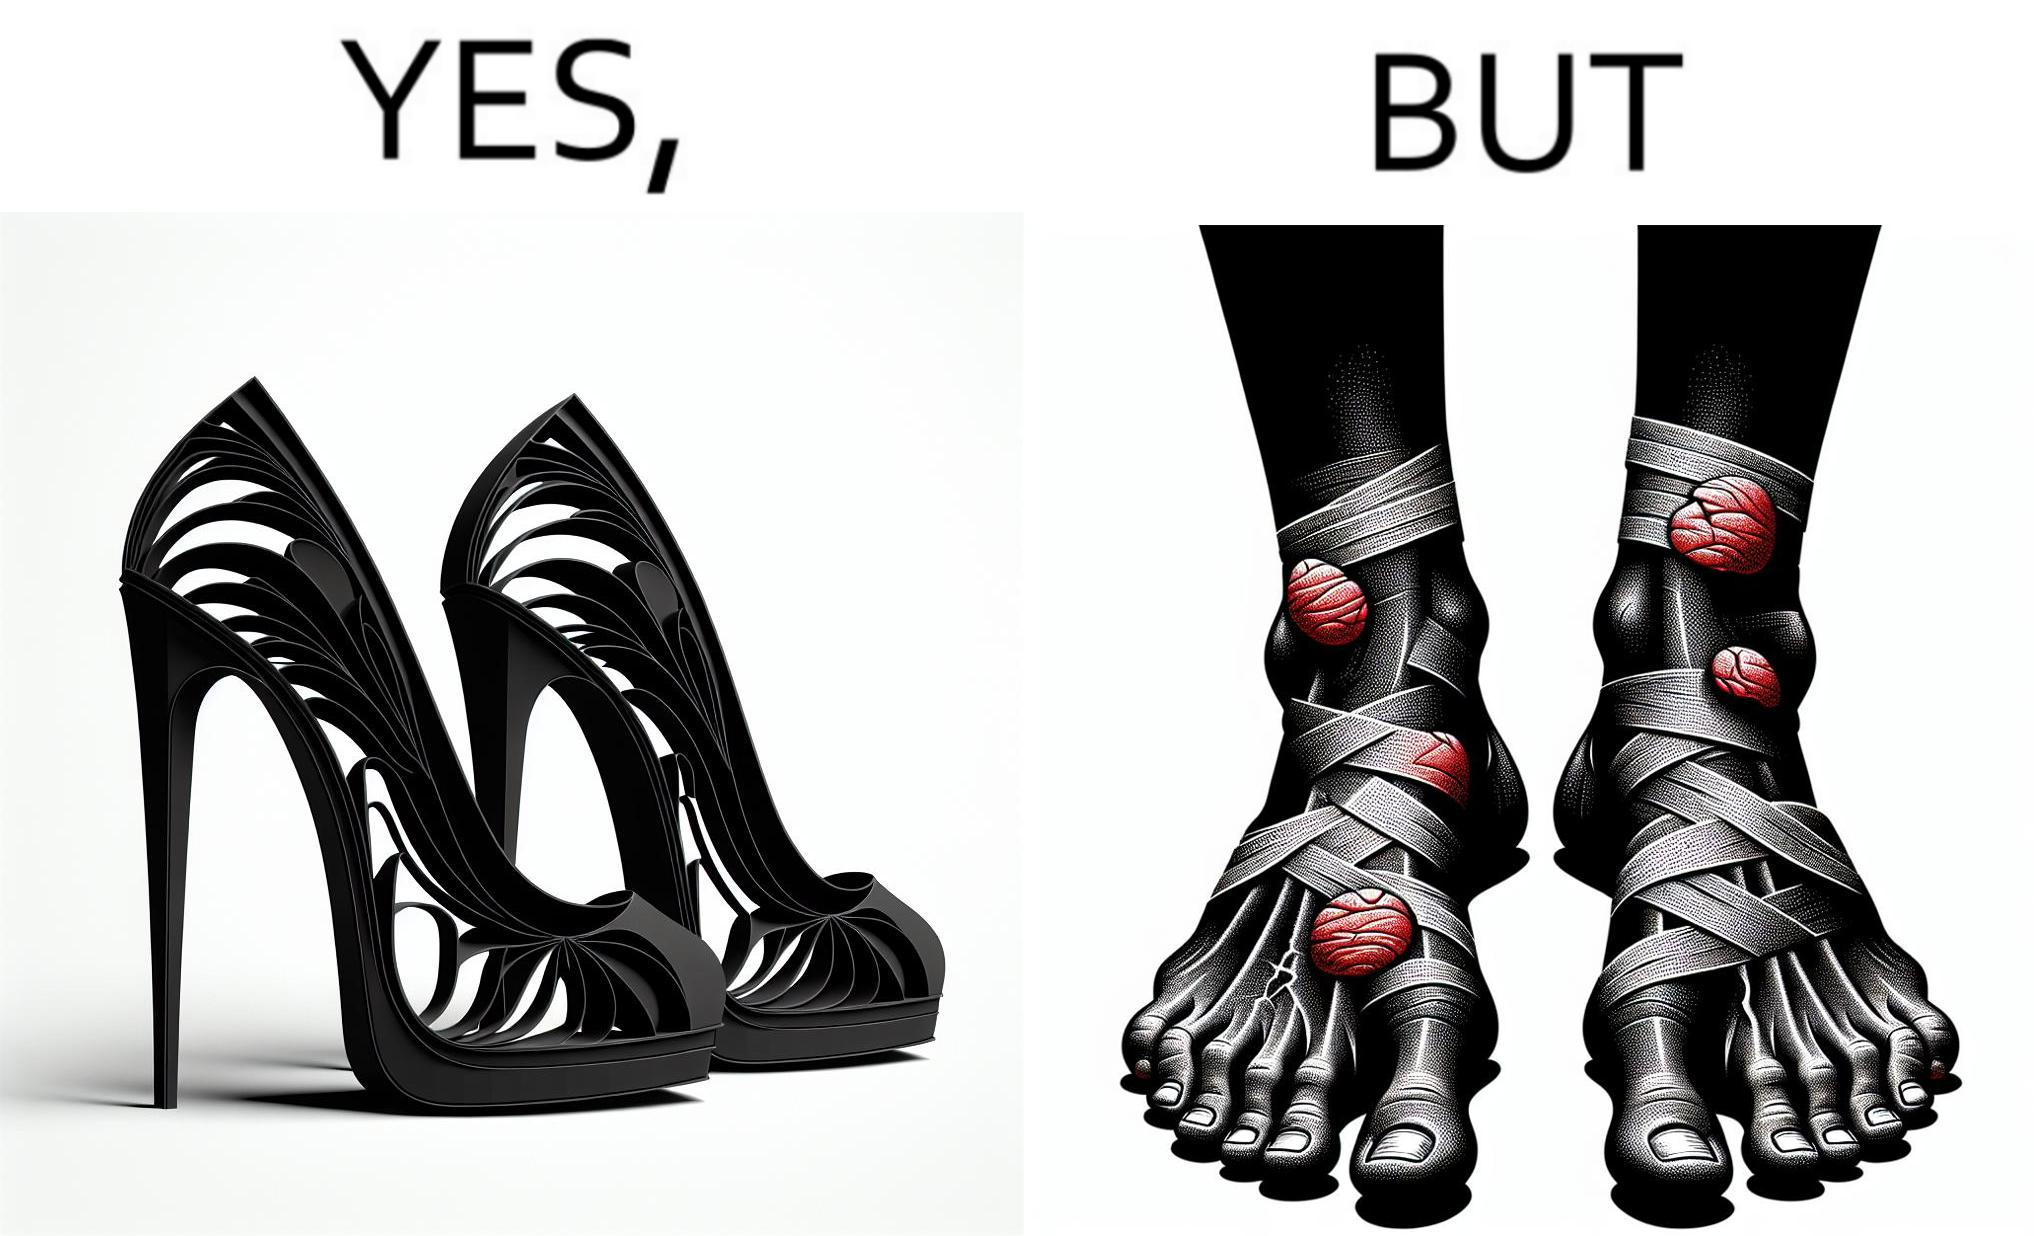Explain the humor or irony in this image. The images are funny since they show how the prettiest footwears like high heels, end up causing a lot of physical discomfort to the user, all in the name fashion 